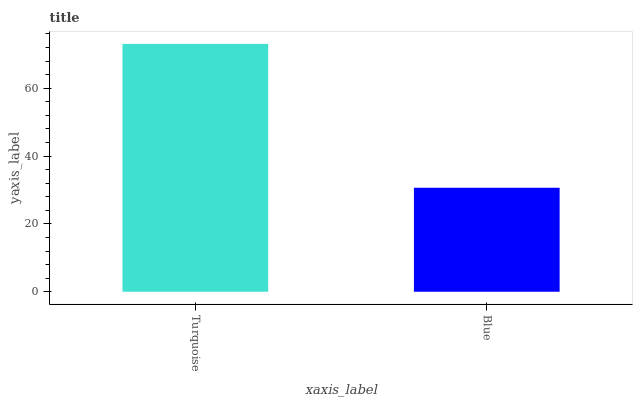Is Blue the minimum?
Answer yes or no. Yes. Is Turquoise the maximum?
Answer yes or no. Yes. Is Blue the maximum?
Answer yes or no. No. Is Turquoise greater than Blue?
Answer yes or no. Yes. Is Blue less than Turquoise?
Answer yes or no. Yes. Is Blue greater than Turquoise?
Answer yes or no. No. Is Turquoise less than Blue?
Answer yes or no. No. Is Turquoise the high median?
Answer yes or no. Yes. Is Blue the low median?
Answer yes or no. Yes. Is Blue the high median?
Answer yes or no. No. Is Turquoise the low median?
Answer yes or no. No. 